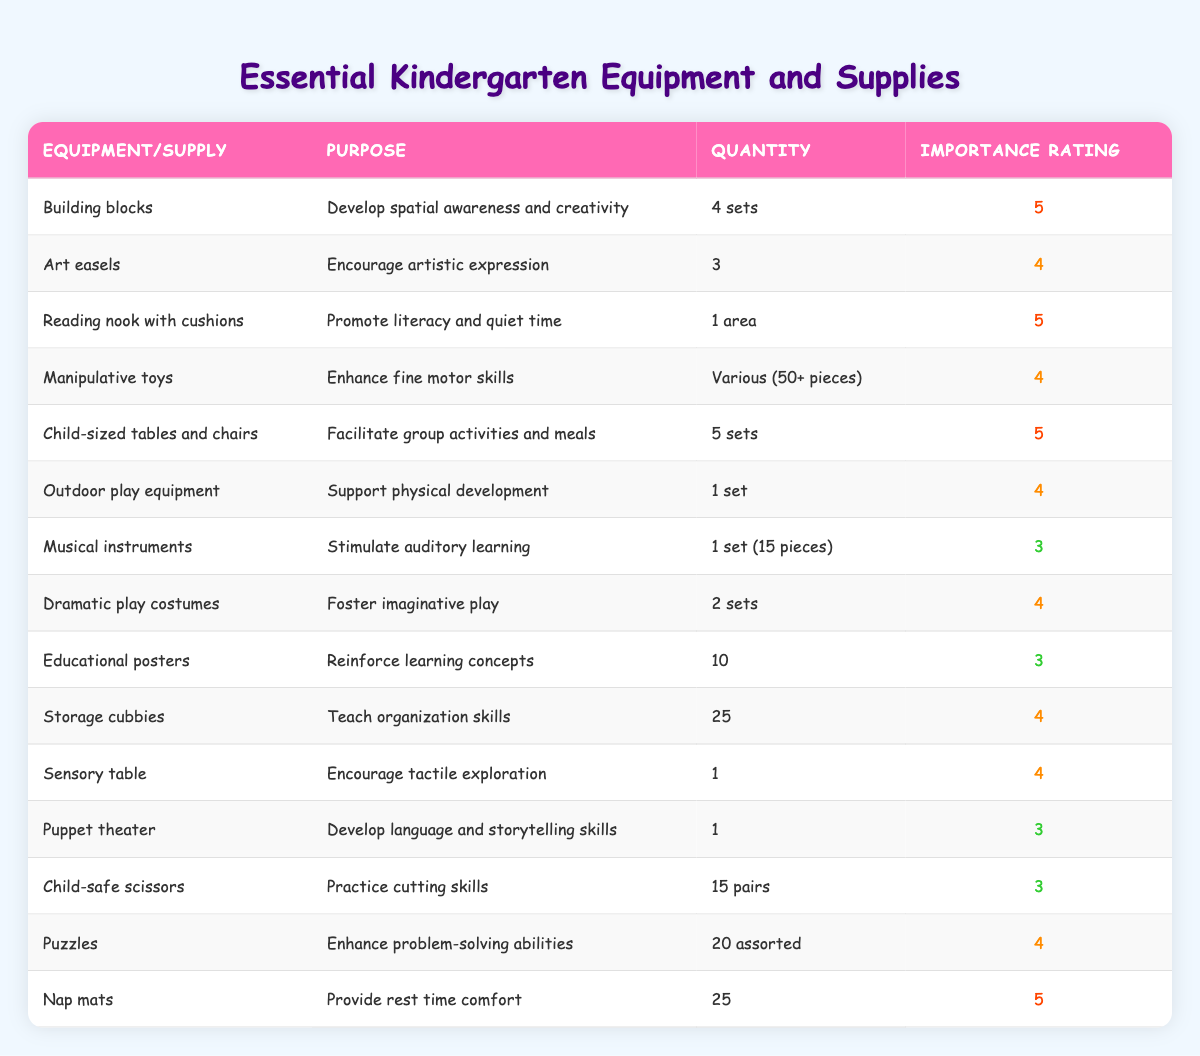What is the purpose of building blocks? The table states that building blocks are used to develop spatial awareness and creativity. This information is directly provided in the "Purpose" column next to the "Building blocks" row.
Answer: Develop spatial awareness and creativity How many sets of child-sized tables and chairs are there? The quantity of child-sized tables and chairs is clearly listed in the "Quantity" column under the "Child-sized tables and chairs" row, which indicates that there are 5 sets.
Answer: 5 sets What is the total number of nap mats and reading nook areas? The total can be calculated by adding the quantities of nap mats (25) from the "Quantity" column under the "Nap mats" row and reading nook areas (1) from the "Reading nook with cushions" row: 25 + 1 = 26.
Answer: 26 Are there more sets of art easels than sets of dramatic play costumes? According to the table, there are 3 art easels and 2 sets of dramatic play costumes. Since 3 is greater than 2, the answer is yes.
Answer: Yes Which equipment has the highest importance rating? By filtering the table for the highest value in the "Importance Rating" column, we find that both "Building blocks," "Reading nook with cushions," "Child-sized tables and chairs," and "Nap mats" all have an importance rating of 5.
Answer: Building blocks, Reading nook with cushions, Child-sized tables and chairs, Nap mats What is the average importance rating for the supplies that support physical development? The supplies supporting physical development are "Outdoor play equipment" (rating 4) and "Building blocks" (rating 5). The average can be calculated as (4 + 5) / 2 = 4.5.
Answer: 4.5 How many pieces are there in total for manipulative toys? The "Quantity" column specifies "Various (50+ pieces)" for manipulative toys, implying there are at least 50 pieces, but no specific total number is given. Thus, the exact total cannot be determined.
Answer: At least 50 pieces Is there a supply for developing language skills listed in the table? The table lists a "Puppet theater" that is used to develop language and storytelling skills, confirming that there is a supply for this purpose.
Answer: Yes What is the difference in the importance ratings between musical instruments and storage cubbies? The importance rating for musical instruments is 3 and for storage cubbies is 4. The difference can be calculated as 4 - 3 = 1.
Answer: 1 